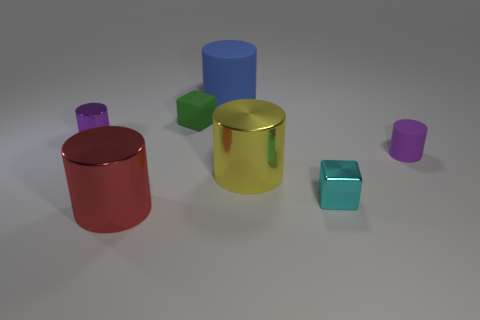Do the object in front of the tiny cyan cube and the purple metal cylinder on the left side of the tiny metallic block have the same size? Upon examining the objects, it appears that the object in front of the tiny cyan cube and the purple metal cylinder do not have the same size. The object in front seems slightly smaller in comparison to the cylindrical shape and size of the purple metal cylinder positioned to the left side of the tiny metallic block. 